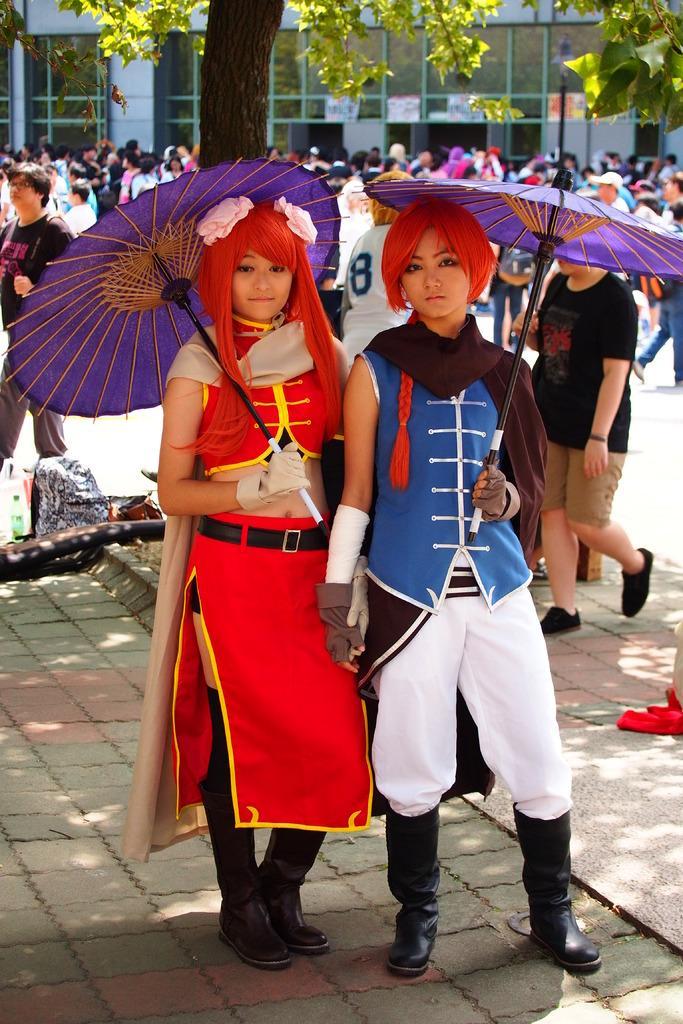In one or two sentences, can you explain what this image depicts? In the foreground of the picture there are two women holding umbrellas and wearing different costumes. In the background there are people standing. At the top there is a tree. In the center of the background there is a building. It is sunny 